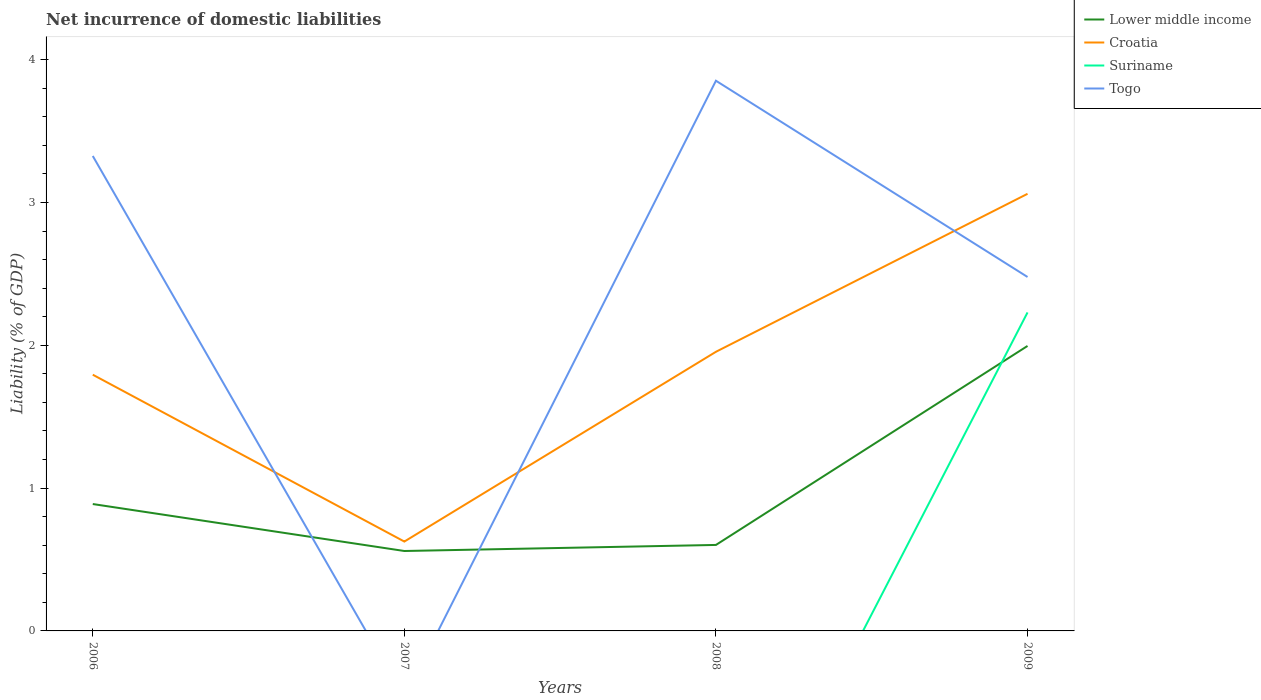How many different coloured lines are there?
Provide a short and direct response. 4. Across all years, what is the maximum net incurrence of domestic liabilities in Lower middle income?
Ensure brevity in your answer.  0.56. What is the total net incurrence of domestic liabilities in Croatia in the graph?
Provide a short and direct response. 1.17. What is the difference between the highest and the second highest net incurrence of domestic liabilities in Togo?
Your answer should be compact. 3.85. How many lines are there?
Offer a very short reply. 4. How many years are there in the graph?
Make the answer very short. 4. What is the difference between two consecutive major ticks on the Y-axis?
Keep it short and to the point. 1. Are the values on the major ticks of Y-axis written in scientific E-notation?
Offer a terse response. No. Where does the legend appear in the graph?
Your answer should be very brief. Top right. How many legend labels are there?
Offer a terse response. 4. How are the legend labels stacked?
Your answer should be very brief. Vertical. What is the title of the graph?
Your response must be concise. Net incurrence of domestic liabilities. What is the label or title of the Y-axis?
Give a very brief answer. Liability (% of GDP). What is the Liability (% of GDP) in Lower middle income in 2006?
Ensure brevity in your answer.  0.89. What is the Liability (% of GDP) in Croatia in 2006?
Offer a very short reply. 1.79. What is the Liability (% of GDP) in Togo in 2006?
Give a very brief answer. 3.33. What is the Liability (% of GDP) in Lower middle income in 2007?
Your response must be concise. 0.56. What is the Liability (% of GDP) of Croatia in 2007?
Ensure brevity in your answer.  0.63. What is the Liability (% of GDP) of Togo in 2007?
Provide a succinct answer. 0. What is the Liability (% of GDP) of Lower middle income in 2008?
Provide a short and direct response. 0.6. What is the Liability (% of GDP) in Croatia in 2008?
Offer a terse response. 1.95. What is the Liability (% of GDP) of Suriname in 2008?
Your answer should be compact. 0. What is the Liability (% of GDP) of Togo in 2008?
Your answer should be compact. 3.85. What is the Liability (% of GDP) of Lower middle income in 2009?
Your answer should be compact. 2. What is the Liability (% of GDP) in Croatia in 2009?
Keep it short and to the point. 3.06. What is the Liability (% of GDP) of Suriname in 2009?
Make the answer very short. 2.23. What is the Liability (% of GDP) of Togo in 2009?
Offer a very short reply. 2.48. Across all years, what is the maximum Liability (% of GDP) of Lower middle income?
Ensure brevity in your answer.  2. Across all years, what is the maximum Liability (% of GDP) in Croatia?
Make the answer very short. 3.06. Across all years, what is the maximum Liability (% of GDP) in Suriname?
Provide a short and direct response. 2.23. Across all years, what is the maximum Liability (% of GDP) in Togo?
Your answer should be compact. 3.85. Across all years, what is the minimum Liability (% of GDP) in Lower middle income?
Offer a very short reply. 0.56. Across all years, what is the minimum Liability (% of GDP) in Croatia?
Offer a terse response. 0.63. Across all years, what is the minimum Liability (% of GDP) of Suriname?
Your answer should be compact. 0. What is the total Liability (% of GDP) of Lower middle income in the graph?
Provide a succinct answer. 4.05. What is the total Liability (% of GDP) in Croatia in the graph?
Provide a short and direct response. 7.44. What is the total Liability (% of GDP) in Suriname in the graph?
Keep it short and to the point. 2.23. What is the total Liability (% of GDP) in Togo in the graph?
Provide a short and direct response. 9.66. What is the difference between the Liability (% of GDP) of Lower middle income in 2006 and that in 2007?
Provide a succinct answer. 0.33. What is the difference between the Liability (% of GDP) of Croatia in 2006 and that in 2007?
Provide a succinct answer. 1.17. What is the difference between the Liability (% of GDP) of Lower middle income in 2006 and that in 2008?
Your answer should be very brief. 0.29. What is the difference between the Liability (% of GDP) of Croatia in 2006 and that in 2008?
Your answer should be very brief. -0.16. What is the difference between the Liability (% of GDP) in Togo in 2006 and that in 2008?
Ensure brevity in your answer.  -0.53. What is the difference between the Liability (% of GDP) of Lower middle income in 2006 and that in 2009?
Make the answer very short. -1.11. What is the difference between the Liability (% of GDP) of Croatia in 2006 and that in 2009?
Your answer should be very brief. -1.27. What is the difference between the Liability (% of GDP) of Togo in 2006 and that in 2009?
Provide a short and direct response. 0.85. What is the difference between the Liability (% of GDP) in Lower middle income in 2007 and that in 2008?
Offer a very short reply. -0.04. What is the difference between the Liability (% of GDP) in Croatia in 2007 and that in 2008?
Your answer should be compact. -1.33. What is the difference between the Liability (% of GDP) of Lower middle income in 2007 and that in 2009?
Make the answer very short. -1.44. What is the difference between the Liability (% of GDP) in Croatia in 2007 and that in 2009?
Offer a very short reply. -2.44. What is the difference between the Liability (% of GDP) of Lower middle income in 2008 and that in 2009?
Make the answer very short. -1.39. What is the difference between the Liability (% of GDP) in Croatia in 2008 and that in 2009?
Give a very brief answer. -1.11. What is the difference between the Liability (% of GDP) of Togo in 2008 and that in 2009?
Offer a very short reply. 1.37. What is the difference between the Liability (% of GDP) of Lower middle income in 2006 and the Liability (% of GDP) of Croatia in 2007?
Your answer should be very brief. 0.26. What is the difference between the Liability (% of GDP) in Lower middle income in 2006 and the Liability (% of GDP) in Croatia in 2008?
Provide a short and direct response. -1.07. What is the difference between the Liability (% of GDP) of Lower middle income in 2006 and the Liability (% of GDP) of Togo in 2008?
Give a very brief answer. -2.96. What is the difference between the Liability (% of GDP) in Croatia in 2006 and the Liability (% of GDP) in Togo in 2008?
Your answer should be compact. -2.06. What is the difference between the Liability (% of GDP) in Lower middle income in 2006 and the Liability (% of GDP) in Croatia in 2009?
Give a very brief answer. -2.17. What is the difference between the Liability (% of GDP) in Lower middle income in 2006 and the Liability (% of GDP) in Suriname in 2009?
Your response must be concise. -1.34. What is the difference between the Liability (% of GDP) of Lower middle income in 2006 and the Liability (% of GDP) of Togo in 2009?
Your answer should be very brief. -1.59. What is the difference between the Liability (% of GDP) in Croatia in 2006 and the Liability (% of GDP) in Suriname in 2009?
Ensure brevity in your answer.  -0.44. What is the difference between the Liability (% of GDP) in Croatia in 2006 and the Liability (% of GDP) in Togo in 2009?
Make the answer very short. -0.68. What is the difference between the Liability (% of GDP) in Lower middle income in 2007 and the Liability (% of GDP) in Croatia in 2008?
Provide a succinct answer. -1.4. What is the difference between the Liability (% of GDP) in Lower middle income in 2007 and the Liability (% of GDP) in Togo in 2008?
Give a very brief answer. -3.29. What is the difference between the Liability (% of GDP) in Croatia in 2007 and the Liability (% of GDP) in Togo in 2008?
Provide a succinct answer. -3.23. What is the difference between the Liability (% of GDP) in Lower middle income in 2007 and the Liability (% of GDP) in Croatia in 2009?
Ensure brevity in your answer.  -2.5. What is the difference between the Liability (% of GDP) in Lower middle income in 2007 and the Liability (% of GDP) in Suriname in 2009?
Provide a succinct answer. -1.67. What is the difference between the Liability (% of GDP) of Lower middle income in 2007 and the Liability (% of GDP) of Togo in 2009?
Offer a very short reply. -1.92. What is the difference between the Liability (% of GDP) in Croatia in 2007 and the Liability (% of GDP) in Suriname in 2009?
Your answer should be compact. -1.6. What is the difference between the Liability (% of GDP) of Croatia in 2007 and the Liability (% of GDP) of Togo in 2009?
Your answer should be compact. -1.85. What is the difference between the Liability (% of GDP) of Lower middle income in 2008 and the Liability (% of GDP) of Croatia in 2009?
Offer a very short reply. -2.46. What is the difference between the Liability (% of GDP) in Lower middle income in 2008 and the Liability (% of GDP) in Suriname in 2009?
Give a very brief answer. -1.63. What is the difference between the Liability (% of GDP) in Lower middle income in 2008 and the Liability (% of GDP) in Togo in 2009?
Offer a very short reply. -1.88. What is the difference between the Liability (% of GDP) in Croatia in 2008 and the Liability (% of GDP) in Suriname in 2009?
Make the answer very short. -0.28. What is the difference between the Liability (% of GDP) in Croatia in 2008 and the Liability (% of GDP) in Togo in 2009?
Provide a short and direct response. -0.52. What is the average Liability (% of GDP) of Lower middle income per year?
Offer a terse response. 1.01. What is the average Liability (% of GDP) in Croatia per year?
Provide a short and direct response. 1.86. What is the average Liability (% of GDP) in Suriname per year?
Offer a very short reply. 0.56. What is the average Liability (% of GDP) of Togo per year?
Make the answer very short. 2.41. In the year 2006, what is the difference between the Liability (% of GDP) of Lower middle income and Liability (% of GDP) of Croatia?
Keep it short and to the point. -0.91. In the year 2006, what is the difference between the Liability (% of GDP) of Lower middle income and Liability (% of GDP) of Togo?
Offer a terse response. -2.44. In the year 2006, what is the difference between the Liability (% of GDP) in Croatia and Liability (% of GDP) in Togo?
Your response must be concise. -1.53. In the year 2007, what is the difference between the Liability (% of GDP) of Lower middle income and Liability (% of GDP) of Croatia?
Your answer should be very brief. -0.07. In the year 2008, what is the difference between the Liability (% of GDP) in Lower middle income and Liability (% of GDP) in Croatia?
Ensure brevity in your answer.  -1.35. In the year 2008, what is the difference between the Liability (% of GDP) of Lower middle income and Liability (% of GDP) of Togo?
Your response must be concise. -3.25. In the year 2008, what is the difference between the Liability (% of GDP) of Croatia and Liability (% of GDP) of Togo?
Your answer should be compact. -1.9. In the year 2009, what is the difference between the Liability (% of GDP) of Lower middle income and Liability (% of GDP) of Croatia?
Provide a short and direct response. -1.07. In the year 2009, what is the difference between the Liability (% of GDP) in Lower middle income and Liability (% of GDP) in Suriname?
Offer a very short reply. -0.23. In the year 2009, what is the difference between the Liability (% of GDP) of Lower middle income and Liability (% of GDP) of Togo?
Give a very brief answer. -0.48. In the year 2009, what is the difference between the Liability (% of GDP) in Croatia and Liability (% of GDP) in Suriname?
Offer a very short reply. 0.83. In the year 2009, what is the difference between the Liability (% of GDP) of Croatia and Liability (% of GDP) of Togo?
Your response must be concise. 0.58. In the year 2009, what is the difference between the Liability (% of GDP) in Suriname and Liability (% of GDP) in Togo?
Offer a terse response. -0.25. What is the ratio of the Liability (% of GDP) in Lower middle income in 2006 to that in 2007?
Provide a short and direct response. 1.59. What is the ratio of the Liability (% of GDP) of Croatia in 2006 to that in 2007?
Offer a terse response. 2.87. What is the ratio of the Liability (% of GDP) of Lower middle income in 2006 to that in 2008?
Provide a succinct answer. 1.48. What is the ratio of the Liability (% of GDP) in Croatia in 2006 to that in 2008?
Provide a succinct answer. 0.92. What is the ratio of the Liability (% of GDP) of Togo in 2006 to that in 2008?
Your answer should be very brief. 0.86. What is the ratio of the Liability (% of GDP) of Lower middle income in 2006 to that in 2009?
Your answer should be compact. 0.45. What is the ratio of the Liability (% of GDP) in Croatia in 2006 to that in 2009?
Ensure brevity in your answer.  0.59. What is the ratio of the Liability (% of GDP) of Togo in 2006 to that in 2009?
Keep it short and to the point. 1.34. What is the ratio of the Liability (% of GDP) in Lower middle income in 2007 to that in 2008?
Offer a very short reply. 0.93. What is the ratio of the Liability (% of GDP) in Croatia in 2007 to that in 2008?
Give a very brief answer. 0.32. What is the ratio of the Liability (% of GDP) of Lower middle income in 2007 to that in 2009?
Keep it short and to the point. 0.28. What is the ratio of the Liability (% of GDP) of Croatia in 2007 to that in 2009?
Offer a terse response. 0.2. What is the ratio of the Liability (% of GDP) in Lower middle income in 2008 to that in 2009?
Your answer should be very brief. 0.3. What is the ratio of the Liability (% of GDP) in Croatia in 2008 to that in 2009?
Your response must be concise. 0.64. What is the ratio of the Liability (% of GDP) of Togo in 2008 to that in 2009?
Your answer should be very brief. 1.55. What is the difference between the highest and the second highest Liability (% of GDP) in Lower middle income?
Your answer should be very brief. 1.11. What is the difference between the highest and the second highest Liability (% of GDP) in Croatia?
Your response must be concise. 1.11. What is the difference between the highest and the second highest Liability (% of GDP) in Togo?
Your response must be concise. 0.53. What is the difference between the highest and the lowest Liability (% of GDP) of Lower middle income?
Offer a very short reply. 1.44. What is the difference between the highest and the lowest Liability (% of GDP) in Croatia?
Keep it short and to the point. 2.44. What is the difference between the highest and the lowest Liability (% of GDP) of Suriname?
Provide a short and direct response. 2.23. What is the difference between the highest and the lowest Liability (% of GDP) of Togo?
Give a very brief answer. 3.85. 